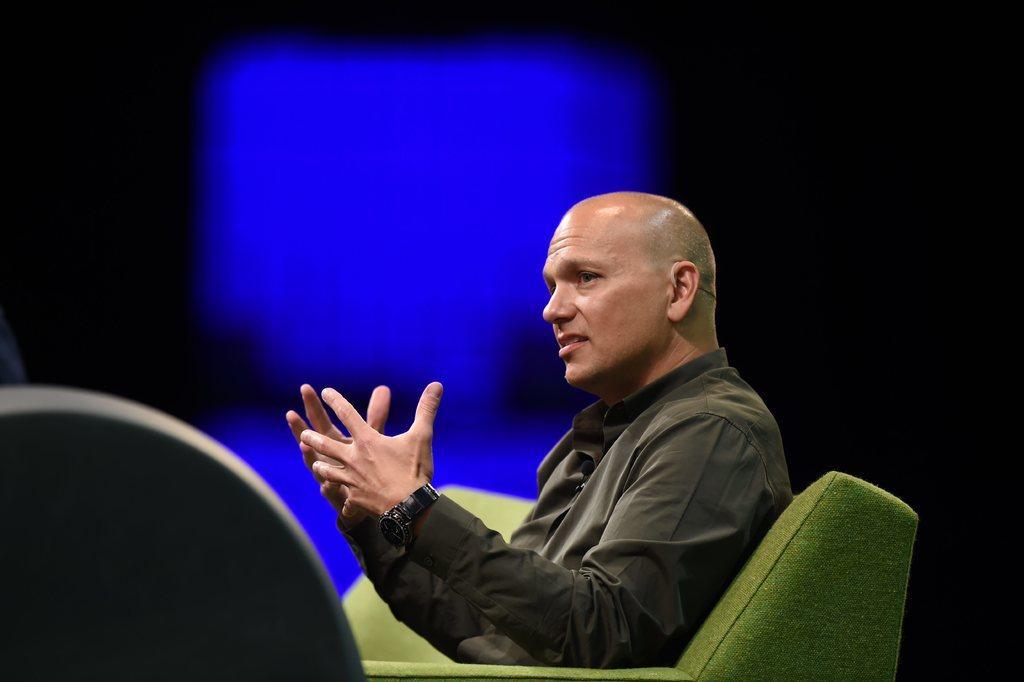Could you give a brief overview of what you see in this image? In the middle of this image, there is a person in a shirt, wearing a watch and sitting on a green color sofa. On the left side, there is an object. In the background, there is a blue color surface. And the background is dark in color. 